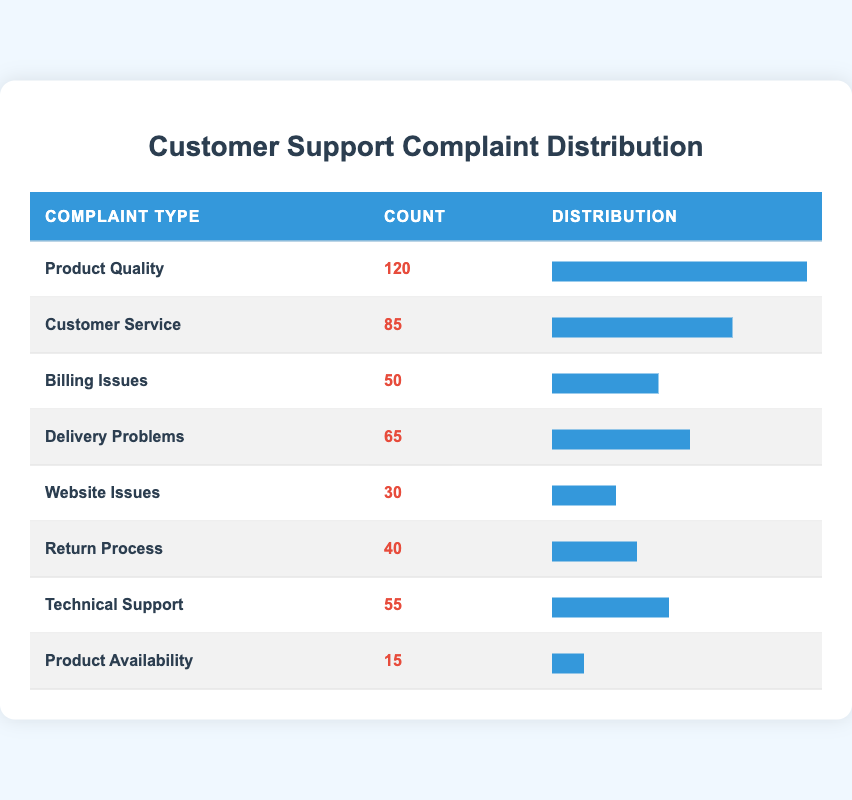What is the type of complaint with the highest count? By looking at the data presented in the table, "Product Quality" has the highest count of 120.
Answer: Product Quality How many complaints are regarding Customer Service? The table directly provides the count of complaints for Customer Service, which is 85.
Answer: 85 What is the total number of complaints across all types? To find the total, we sum the counts of all the complaint types: 120 + 85 + 50 + 65 + 30 + 40 + 55 + 15 = 460.
Answer: 460 Is the number of complaints for Website Issues greater than that for Product Availability? The table shows that the count for Website Issues is 30, while for Product Availability, it is 15. Since 30 is greater than 15, the statement is true.
Answer: Yes Which complaint types have counts below 50? To identify these, we look for counts less than 50 in the table: "Product Availability" (15) and "Website Issues" (30) both have counts below 50.
Answer: Product Availability and Website Issues What percentage of total complaints does "Billing Issues" represent? First, we determine the count for Billing Issues, which is 50. To find the percentage, we calculate (50/460) * 100 ≈ 10.87%.
Answer: Approximately 10.87% Which two types of complaints have the closest counts and what are those counts? By examining the counts, "Technical Support" has 55 and "Delivery Problems" has 65. The difference between these counts is small at 10.
Answer: 55 and 65 What is the average number of complaints per type? There are 8 complaint types. We already found the total number of complaints is 460. The average is calculated by dividing the total by the number of types: 460/8 = 57.5.
Answer: 57.5 Are there more complaints about Delivery Problems than there are for Return Process? The table shows Delivery Problems have 65 complaints while Return Process has 40. Since 65 is greater than 40, this statement is true.
Answer: Yes 